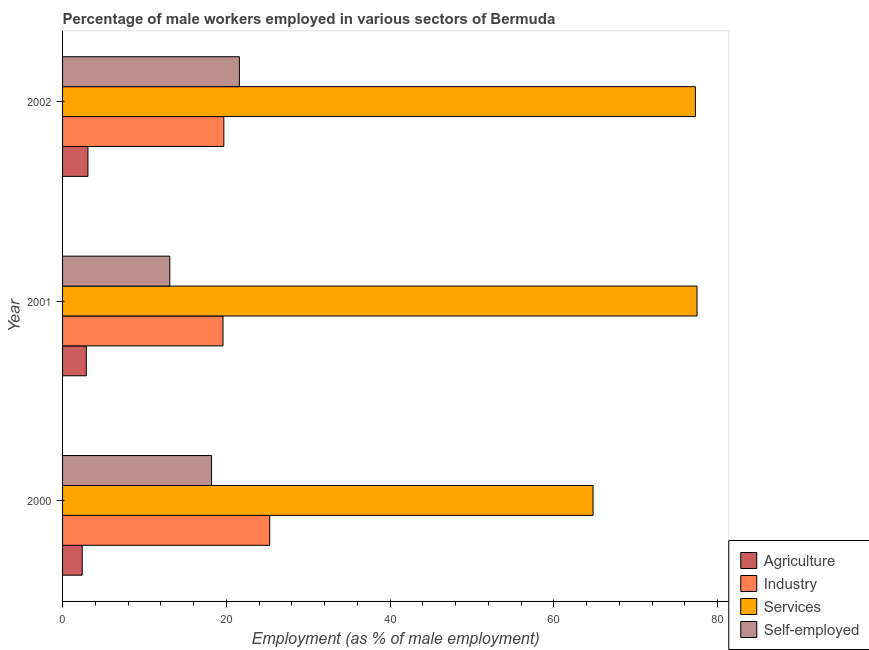How many different coloured bars are there?
Your answer should be compact. 4. Are the number of bars per tick equal to the number of legend labels?
Your response must be concise. Yes. How many bars are there on the 3rd tick from the top?
Offer a terse response. 4. What is the percentage of male workers in agriculture in 2002?
Give a very brief answer. 3.1. Across all years, what is the maximum percentage of male workers in industry?
Provide a short and direct response. 25.3. Across all years, what is the minimum percentage of male workers in agriculture?
Provide a succinct answer. 2.4. In which year was the percentage of self employed male workers maximum?
Provide a succinct answer. 2002. In which year was the percentage of male workers in agriculture minimum?
Your response must be concise. 2000. What is the total percentage of male workers in agriculture in the graph?
Make the answer very short. 8.4. What is the difference between the percentage of male workers in industry in 2000 and the percentage of male workers in services in 2001?
Provide a short and direct response. -52.2. What is the average percentage of male workers in industry per year?
Keep it short and to the point. 21.53. In the year 2002, what is the difference between the percentage of self employed male workers and percentage of male workers in services?
Keep it short and to the point. -55.7. In how many years, is the percentage of male workers in industry greater than 32 %?
Make the answer very short. 0. What is the ratio of the percentage of self employed male workers in 2000 to that in 2002?
Make the answer very short. 0.84. Is the difference between the percentage of self employed male workers in 2000 and 2001 greater than the difference between the percentage of male workers in services in 2000 and 2001?
Your response must be concise. Yes. What is the difference between the highest and the second highest percentage of self employed male workers?
Offer a very short reply. 3.4. In how many years, is the percentage of male workers in industry greater than the average percentage of male workers in industry taken over all years?
Your response must be concise. 1. Is the sum of the percentage of male workers in services in 2000 and 2002 greater than the maximum percentage of male workers in industry across all years?
Your answer should be compact. Yes. What does the 3rd bar from the top in 2002 represents?
Your answer should be very brief. Industry. What does the 3rd bar from the bottom in 2001 represents?
Offer a very short reply. Services. How many years are there in the graph?
Provide a succinct answer. 3. How are the legend labels stacked?
Provide a short and direct response. Vertical. What is the title of the graph?
Keep it short and to the point. Percentage of male workers employed in various sectors of Bermuda. What is the label or title of the X-axis?
Ensure brevity in your answer.  Employment (as % of male employment). What is the Employment (as % of male employment) in Agriculture in 2000?
Ensure brevity in your answer.  2.4. What is the Employment (as % of male employment) of Industry in 2000?
Your answer should be very brief. 25.3. What is the Employment (as % of male employment) of Services in 2000?
Your answer should be very brief. 64.8. What is the Employment (as % of male employment) in Self-employed in 2000?
Ensure brevity in your answer.  18.2. What is the Employment (as % of male employment) in Agriculture in 2001?
Your response must be concise. 2.9. What is the Employment (as % of male employment) in Industry in 2001?
Ensure brevity in your answer.  19.6. What is the Employment (as % of male employment) of Services in 2001?
Offer a very short reply. 77.5. What is the Employment (as % of male employment) in Self-employed in 2001?
Ensure brevity in your answer.  13.1. What is the Employment (as % of male employment) of Agriculture in 2002?
Offer a terse response. 3.1. What is the Employment (as % of male employment) in Industry in 2002?
Your answer should be compact. 19.7. What is the Employment (as % of male employment) of Services in 2002?
Offer a very short reply. 77.3. What is the Employment (as % of male employment) in Self-employed in 2002?
Your answer should be compact. 21.6. Across all years, what is the maximum Employment (as % of male employment) of Agriculture?
Your answer should be very brief. 3.1. Across all years, what is the maximum Employment (as % of male employment) of Industry?
Provide a short and direct response. 25.3. Across all years, what is the maximum Employment (as % of male employment) of Services?
Ensure brevity in your answer.  77.5. Across all years, what is the maximum Employment (as % of male employment) in Self-employed?
Provide a short and direct response. 21.6. Across all years, what is the minimum Employment (as % of male employment) in Agriculture?
Give a very brief answer. 2.4. Across all years, what is the minimum Employment (as % of male employment) in Industry?
Give a very brief answer. 19.6. Across all years, what is the minimum Employment (as % of male employment) in Services?
Provide a succinct answer. 64.8. Across all years, what is the minimum Employment (as % of male employment) of Self-employed?
Your response must be concise. 13.1. What is the total Employment (as % of male employment) in Industry in the graph?
Give a very brief answer. 64.6. What is the total Employment (as % of male employment) in Services in the graph?
Offer a terse response. 219.6. What is the total Employment (as % of male employment) of Self-employed in the graph?
Make the answer very short. 52.9. What is the difference between the Employment (as % of male employment) in Agriculture in 2000 and that in 2001?
Make the answer very short. -0.5. What is the difference between the Employment (as % of male employment) in Services in 2000 and that in 2001?
Your answer should be compact. -12.7. What is the difference between the Employment (as % of male employment) of Self-employed in 2000 and that in 2001?
Offer a terse response. 5.1. What is the difference between the Employment (as % of male employment) of Agriculture in 2000 and that in 2002?
Provide a succinct answer. -0.7. What is the difference between the Employment (as % of male employment) in Self-employed in 2000 and that in 2002?
Your response must be concise. -3.4. What is the difference between the Employment (as % of male employment) in Agriculture in 2000 and the Employment (as % of male employment) in Industry in 2001?
Your answer should be very brief. -17.2. What is the difference between the Employment (as % of male employment) in Agriculture in 2000 and the Employment (as % of male employment) in Services in 2001?
Your response must be concise. -75.1. What is the difference between the Employment (as % of male employment) of Agriculture in 2000 and the Employment (as % of male employment) of Self-employed in 2001?
Your answer should be compact. -10.7. What is the difference between the Employment (as % of male employment) in Industry in 2000 and the Employment (as % of male employment) in Services in 2001?
Provide a short and direct response. -52.2. What is the difference between the Employment (as % of male employment) in Services in 2000 and the Employment (as % of male employment) in Self-employed in 2001?
Make the answer very short. 51.7. What is the difference between the Employment (as % of male employment) in Agriculture in 2000 and the Employment (as % of male employment) in Industry in 2002?
Give a very brief answer. -17.3. What is the difference between the Employment (as % of male employment) in Agriculture in 2000 and the Employment (as % of male employment) in Services in 2002?
Keep it short and to the point. -74.9. What is the difference between the Employment (as % of male employment) in Agriculture in 2000 and the Employment (as % of male employment) in Self-employed in 2002?
Give a very brief answer. -19.2. What is the difference between the Employment (as % of male employment) of Industry in 2000 and the Employment (as % of male employment) of Services in 2002?
Ensure brevity in your answer.  -52. What is the difference between the Employment (as % of male employment) of Services in 2000 and the Employment (as % of male employment) of Self-employed in 2002?
Your response must be concise. 43.2. What is the difference between the Employment (as % of male employment) of Agriculture in 2001 and the Employment (as % of male employment) of Industry in 2002?
Keep it short and to the point. -16.8. What is the difference between the Employment (as % of male employment) in Agriculture in 2001 and the Employment (as % of male employment) in Services in 2002?
Offer a terse response. -74.4. What is the difference between the Employment (as % of male employment) of Agriculture in 2001 and the Employment (as % of male employment) of Self-employed in 2002?
Your answer should be compact. -18.7. What is the difference between the Employment (as % of male employment) in Industry in 2001 and the Employment (as % of male employment) in Services in 2002?
Offer a very short reply. -57.7. What is the difference between the Employment (as % of male employment) in Industry in 2001 and the Employment (as % of male employment) in Self-employed in 2002?
Ensure brevity in your answer.  -2. What is the difference between the Employment (as % of male employment) in Services in 2001 and the Employment (as % of male employment) in Self-employed in 2002?
Your answer should be very brief. 55.9. What is the average Employment (as % of male employment) in Industry per year?
Your response must be concise. 21.53. What is the average Employment (as % of male employment) in Services per year?
Give a very brief answer. 73.2. What is the average Employment (as % of male employment) in Self-employed per year?
Give a very brief answer. 17.63. In the year 2000, what is the difference between the Employment (as % of male employment) in Agriculture and Employment (as % of male employment) in Industry?
Keep it short and to the point. -22.9. In the year 2000, what is the difference between the Employment (as % of male employment) in Agriculture and Employment (as % of male employment) in Services?
Offer a terse response. -62.4. In the year 2000, what is the difference between the Employment (as % of male employment) of Agriculture and Employment (as % of male employment) of Self-employed?
Keep it short and to the point. -15.8. In the year 2000, what is the difference between the Employment (as % of male employment) of Industry and Employment (as % of male employment) of Services?
Ensure brevity in your answer.  -39.5. In the year 2000, what is the difference between the Employment (as % of male employment) of Services and Employment (as % of male employment) of Self-employed?
Your answer should be compact. 46.6. In the year 2001, what is the difference between the Employment (as % of male employment) of Agriculture and Employment (as % of male employment) of Industry?
Provide a short and direct response. -16.7. In the year 2001, what is the difference between the Employment (as % of male employment) of Agriculture and Employment (as % of male employment) of Services?
Your response must be concise. -74.6. In the year 2001, what is the difference between the Employment (as % of male employment) of Agriculture and Employment (as % of male employment) of Self-employed?
Your answer should be compact. -10.2. In the year 2001, what is the difference between the Employment (as % of male employment) in Industry and Employment (as % of male employment) in Services?
Your answer should be compact. -57.9. In the year 2001, what is the difference between the Employment (as % of male employment) in Services and Employment (as % of male employment) in Self-employed?
Make the answer very short. 64.4. In the year 2002, what is the difference between the Employment (as % of male employment) of Agriculture and Employment (as % of male employment) of Industry?
Offer a terse response. -16.6. In the year 2002, what is the difference between the Employment (as % of male employment) in Agriculture and Employment (as % of male employment) in Services?
Provide a succinct answer. -74.2. In the year 2002, what is the difference between the Employment (as % of male employment) in Agriculture and Employment (as % of male employment) in Self-employed?
Your answer should be very brief. -18.5. In the year 2002, what is the difference between the Employment (as % of male employment) in Industry and Employment (as % of male employment) in Services?
Your answer should be compact. -57.6. In the year 2002, what is the difference between the Employment (as % of male employment) of Services and Employment (as % of male employment) of Self-employed?
Make the answer very short. 55.7. What is the ratio of the Employment (as % of male employment) in Agriculture in 2000 to that in 2001?
Make the answer very short. 0.83. What is the ratio of the Employment (as % of male employment) of Industry in 2000 to that in 2001?
Make the answer very short. 1.29. What is the ratio of the Employment (as % of male employment) of Services in 2000 to that in 2001?
Your response must be concise. 0.84. What is the ratio of the Employment (as % of male employment) of Self-employed in 2000 to that in 2001?
Ensure brevity in your answer.  1.39. What is the ratio of the Employment (as % of male employment) in Agriculture in 2000 to that in 2002?
Offer a very short reply. 0.77. What is the ratio of the Employment (as % of male employment) of Industry in 2000 to that in 2002?
Give a very brief answer. 1.28. What is the ratio of the Employment (as % of male employment) of Services in 2000 to that in 2002?
Offer a terse response. 0.84. What is the ratio of the Employment (as % of male employment) of Self-employed in 2000 to that in 2002?
Your answer should be compact. 0.84. What is the ratio of the Employment (as % of male employment) of Agriculture in 2001 to that in 2002?
Your answer should be compact. 0.94. What is the ratio of the Employment (as % of male employment) in Industry in 2001 to that in 2002?
Ensure brevity in your answer.  0.99. What is the ratio of the Employment (as % of male employment) of Self-employed in 2001 to that in 2002?
Keep it short and to the point. 0.61. What is the difference between the highest and the second highest Employment (as % of male employment) of Agriculture?
Your answer should be very brief. 0.2. What is the difference between the highest and the lowest Employment (as % of male employment) in Agriculture?
Make the answer very short. 0.7. What is the difference between the highest and the lowest Employment (as % of male employment) in Services?
Provide a short and direct response. 12.7. What is the difference between the highest and the lowest Employment (as % of male employment) of Self-employed?
Your response must be concise. 8.5. 